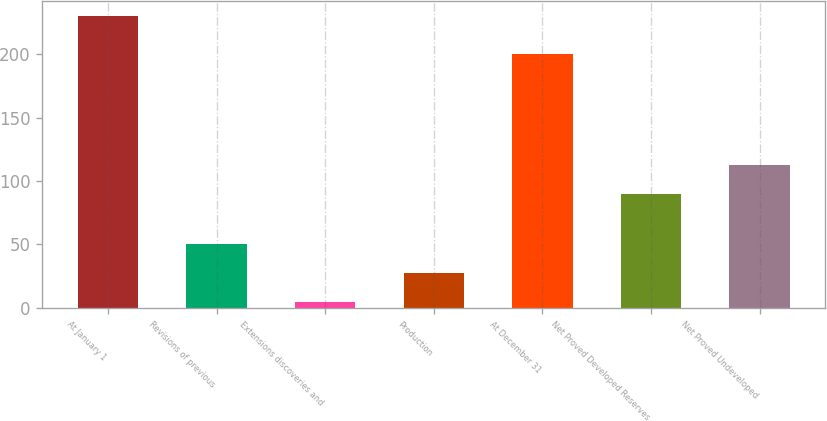Convert chart. <chart><loc_0><loc_0><loc_500><loc_500><bar_chart><fcel>At January 1<fcel>Revisions of previous<fcel>Extensions discoveries and<fcel>Production<fcel>At December 31<fcel>Net Proved Developed Reserves<fcel>Net Proved Undeveloped<nl><fcel>230<fcel>50<fcel>5<fcel>27.5<fcel>200<fcel>90<fcel>112.5<nl></chart> 